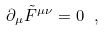<formula> <loc_0><loc_0><loc_500><loc_500>\partial _ { \mu } \tilde { F } ^ { \mu \nu } = 0 \ ,</formula> 